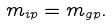<formula> <loc_0><loc_0><loc_500><loc_500>m _ { i p } = m _ { g p } .</formula> 